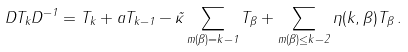Convert formula to latex. <formula><loc_0><loc_0><loc_500><loc_500>D T _ { k } D ^ { - 1 } = T _ { k } + a T _ { k - 1 } - \tilde { \kappa } \sum _ { m ( \beta ) = k - 1 } T _ { \beta } + \sum _ { m ( \beta ) \leq k - 2 } \eta ( k , \beta ) T _ { \beta } \, .</formula> 